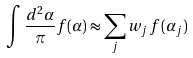<formula> <loc_0><loc_0><loc_500><loc_500>\int \frac { d ^ { 2 } \alpha } { \pi } f ( \alpha ) \approx \sum _ { j } w _ { j } \, f ( \alpha _ { j } )</formula> 